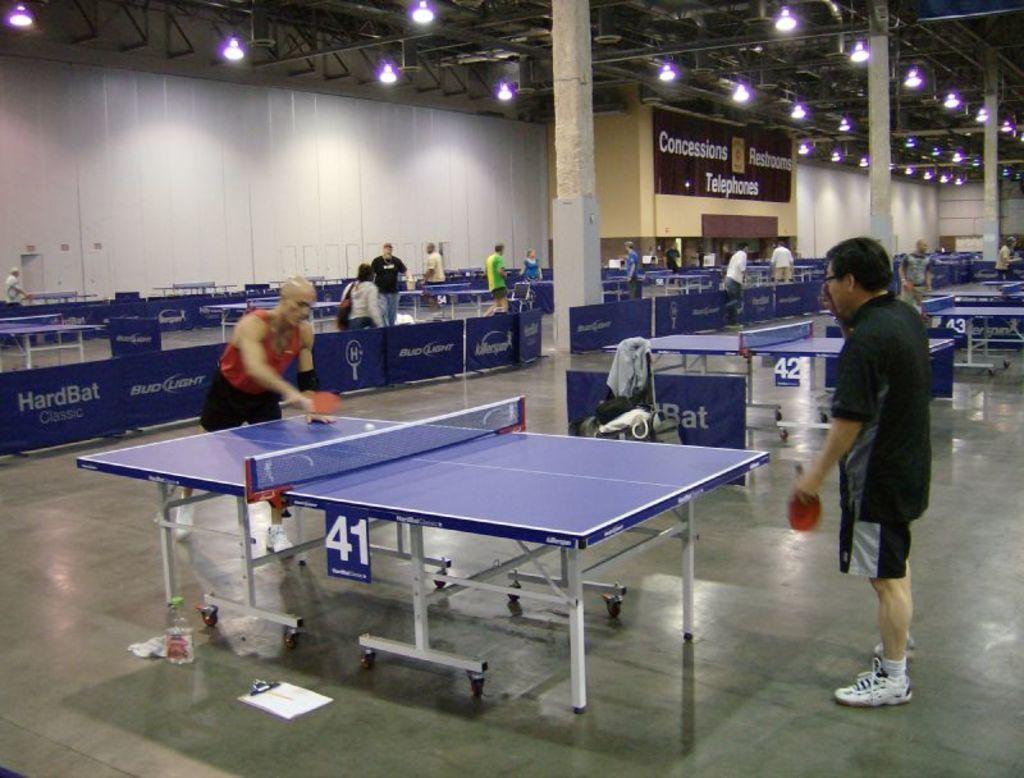In one or two sentences, can you explain what this image depicts? In this picture there are two person standing in the foreground and holding the bats and there is a ball on the table. At the back there are tables and there are group of people and there is a board on the wall and there is text on the board. At the top there are lights. At the bottom there is a floor. 